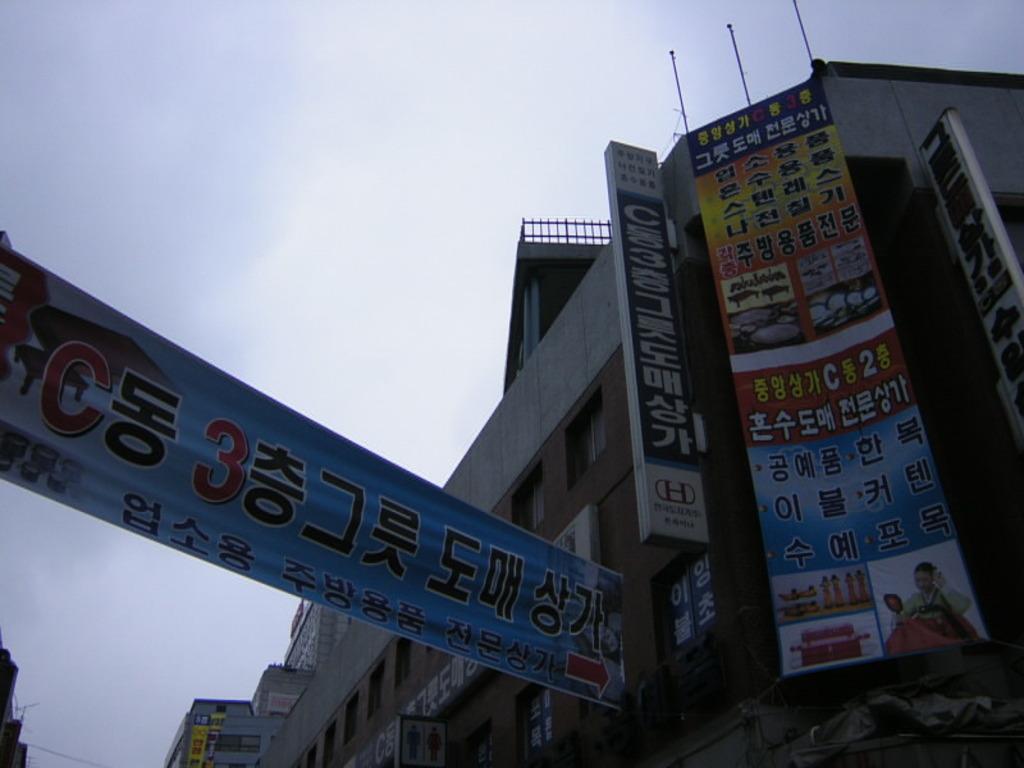In one or two sentences, can you explain what this image depicts? On the left side, there is a blue color banner arranged. On the right side, there are banners and hoardings attached to the walls of the buildings, which are having windows. In the background, there are clouds in the blue sky. 